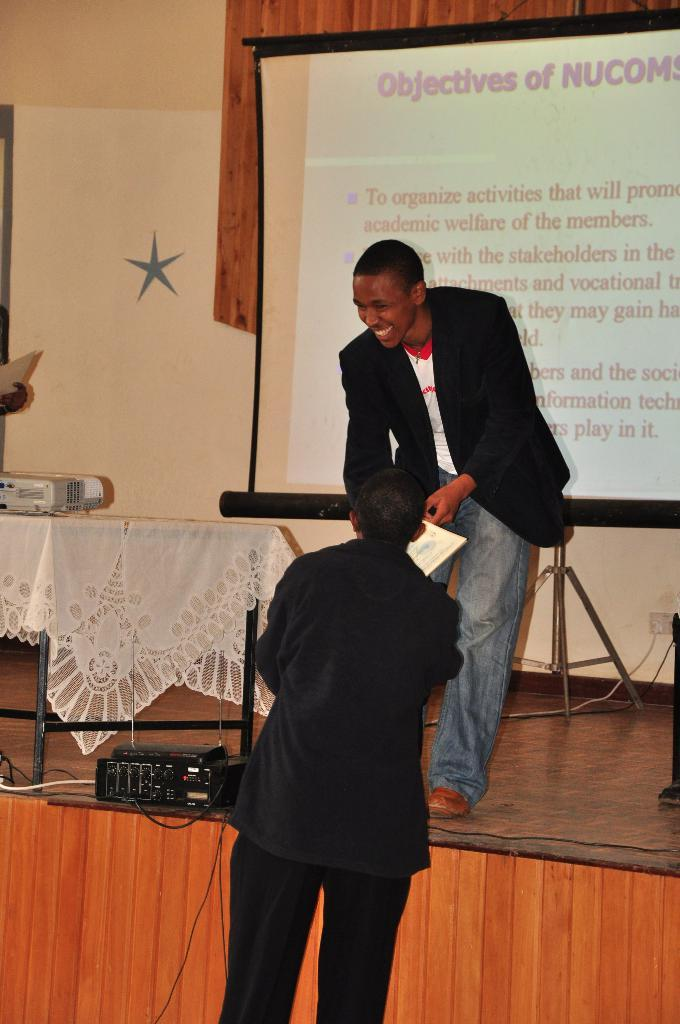How many people are in the image? There are two men standing in the image. What can be seen on the screen in the image? The facts do not specify what is on the screen, so we cannot answer that question definitively. What type of object is visible in the image that is used for connecting devices? There are cables visible in the image that are used for connecting devices. What type of structure is present in the image? There is a wall in the image. What type of beetle can be seen crawling on the cushion in the image? There is no beetle or cushion present in the image. What part of the brain is visible in the image? There is no brain present in the image. 